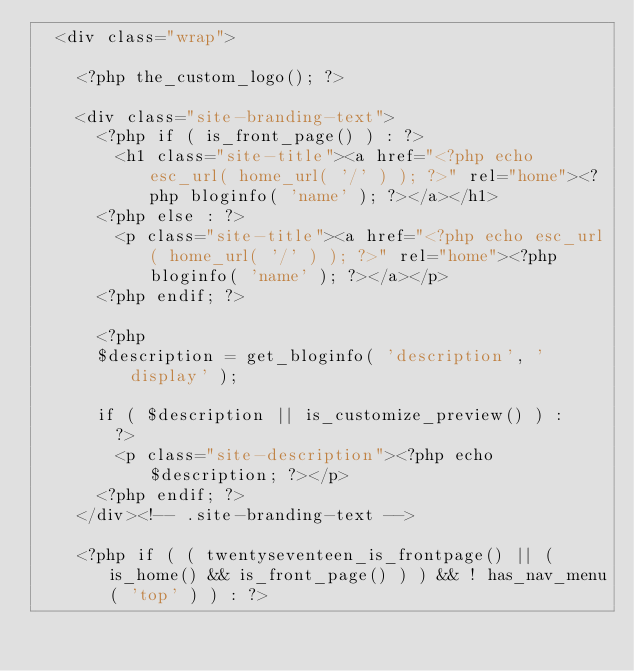<code> <loc_0><loc_0><loc_500><loc_500><_PHP_>	<div class="wrap">

		<?php the_custom_logo(); ?>

		<div class="site-branding-text">
			<?php if ( is_front_page() ) : ?>
				<h1 class="site-title"><a href="<?php echo esc_url( home_url( '/' ) ); ?>" rel="home"><?php bloginfo( 'name' ); ?></a></h1>
			<?php else : ?>
				<p class="site-title"><a href="<?php echo esc_url( home_url( '/' ) ); ?>" rel="home"><?php bloginfo( 'name' ); ?></a></p>
			<?php endif; ?>

			<?php
			$description = get_bloginfo( 'description', 'display' );

			if ( $description || is_customize_preview() ) :
				?>
				<p class="site-description"><?php echo $description; ?></p>
			<?php endif; ?>
		</div><!-- .site-branding-text -->

		<?php if ( ( twentyseventeen_is_frontpage() || ( is_home() && is_front_page() ) ) && ! has_nav_menu( 'top' ) ) : ?></code> 